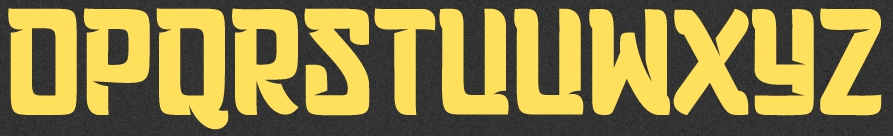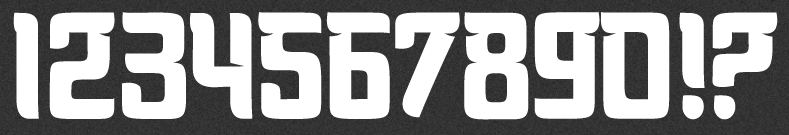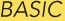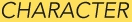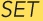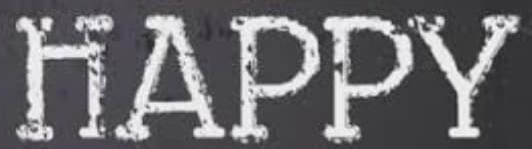Identify the words shown in these images in order, separated by a semicolon. OPQRSTUVWXYZ; 1234567890!?; BASIC; CHARACTER; SET; HAPPY 